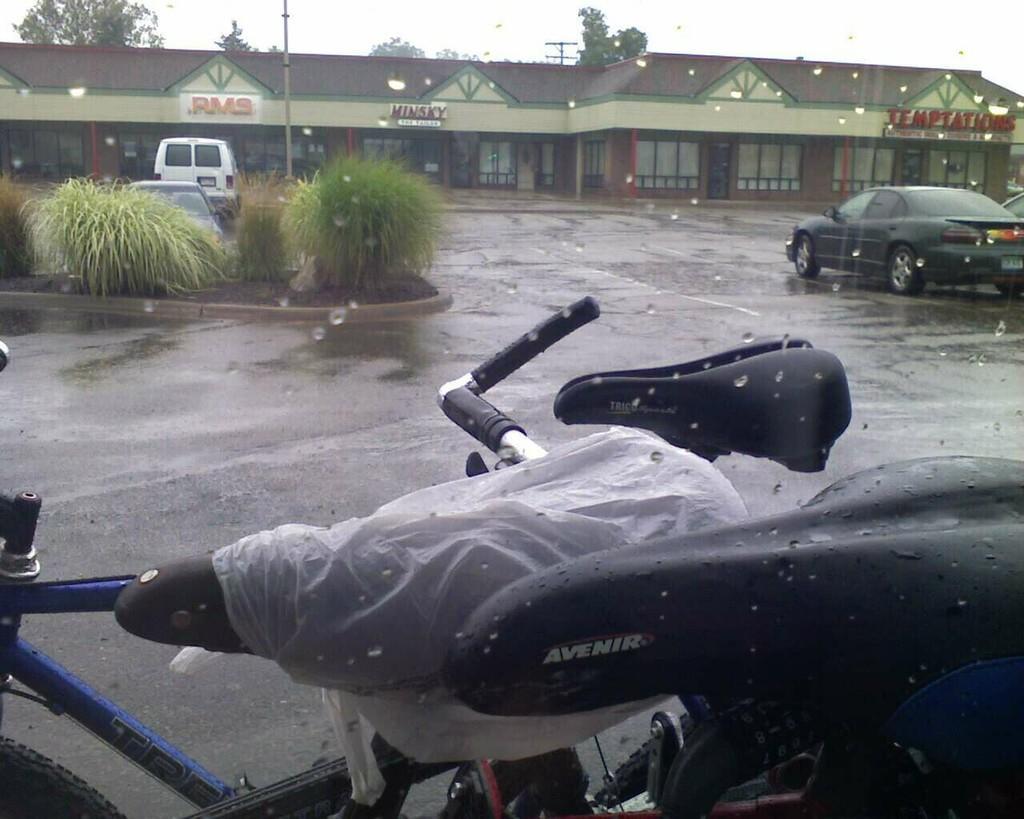Describe this image in one or two sentences. In this image we can see cycles. In the back there are plants and vehicles. Also there is a building with names. In the background there are trees and sky. And there are water droplets in the image. 